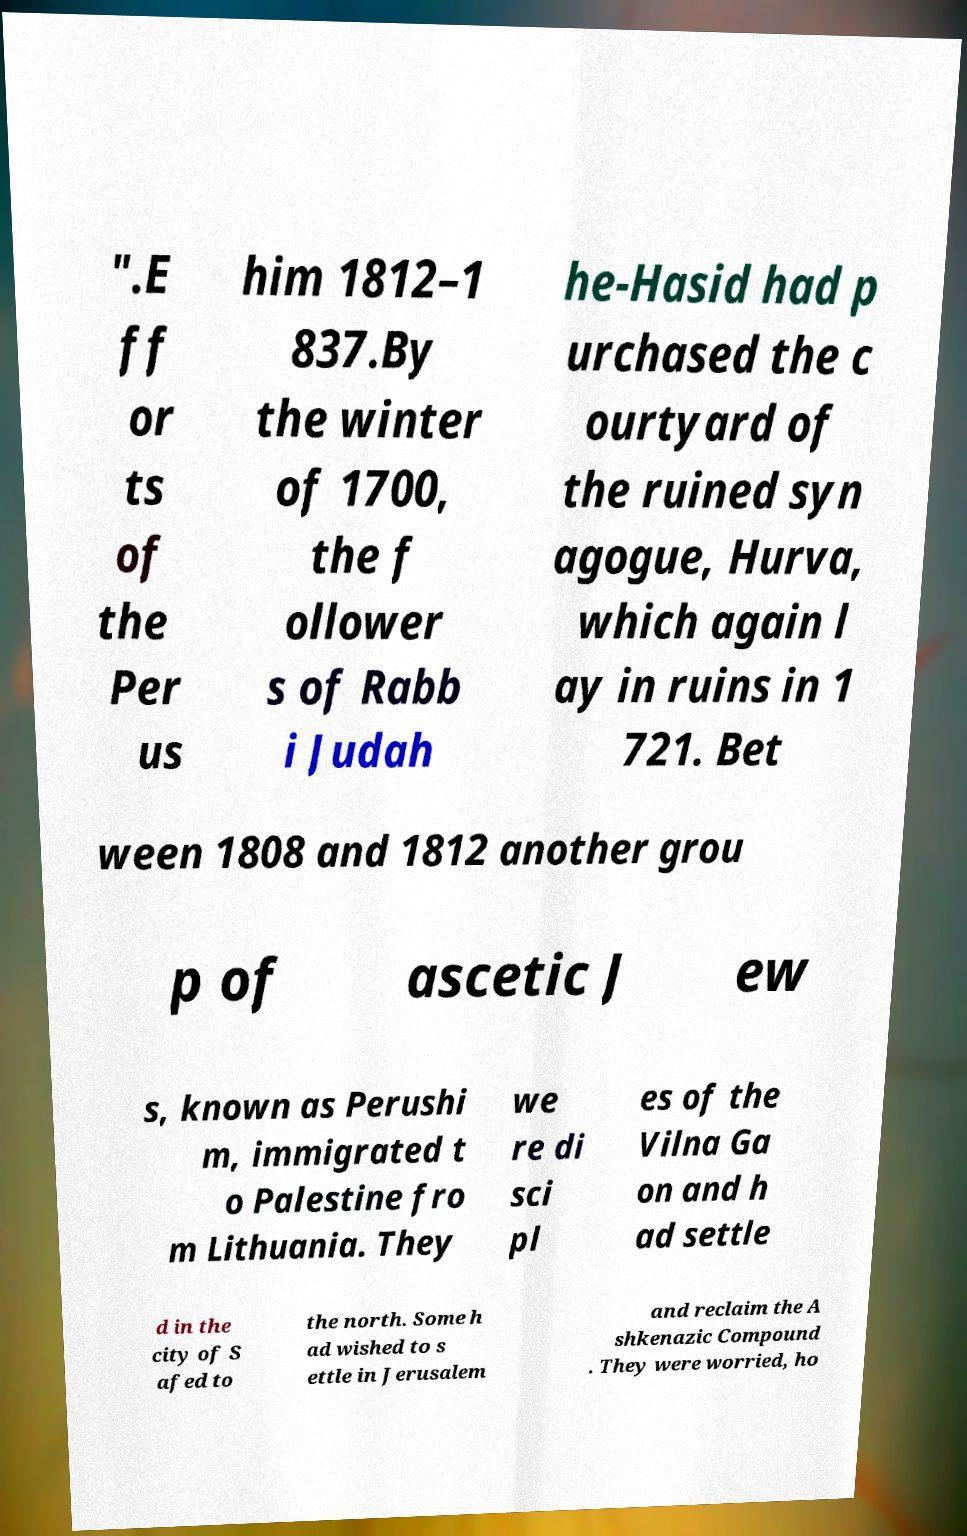Can you read and provide the text displayed in the image?This photo seems to have some interesting text. Can you extract and type it out for me? ".E ff or ts of the Per us him 1812–1 837.By the winter of 1700, the f ollower s of Rabb i Judah he-Hasid had p urchased the c ourtyard of the ruined syn agogue, Hurva, which again l ay in ruins in 1 721. Bet ween 1808 and 1812 another grou p of ascetic J ew s, known as Perushi m, immigrated t o Palestine fro m Lithuania. They we re di sci pl es of the Vilna Ga on and h ad settle d in the city of S afed to the north. Some h ad wished to s ettle in Jerusalem and reclaim the A shkenazic Compound . They were worried, ho 